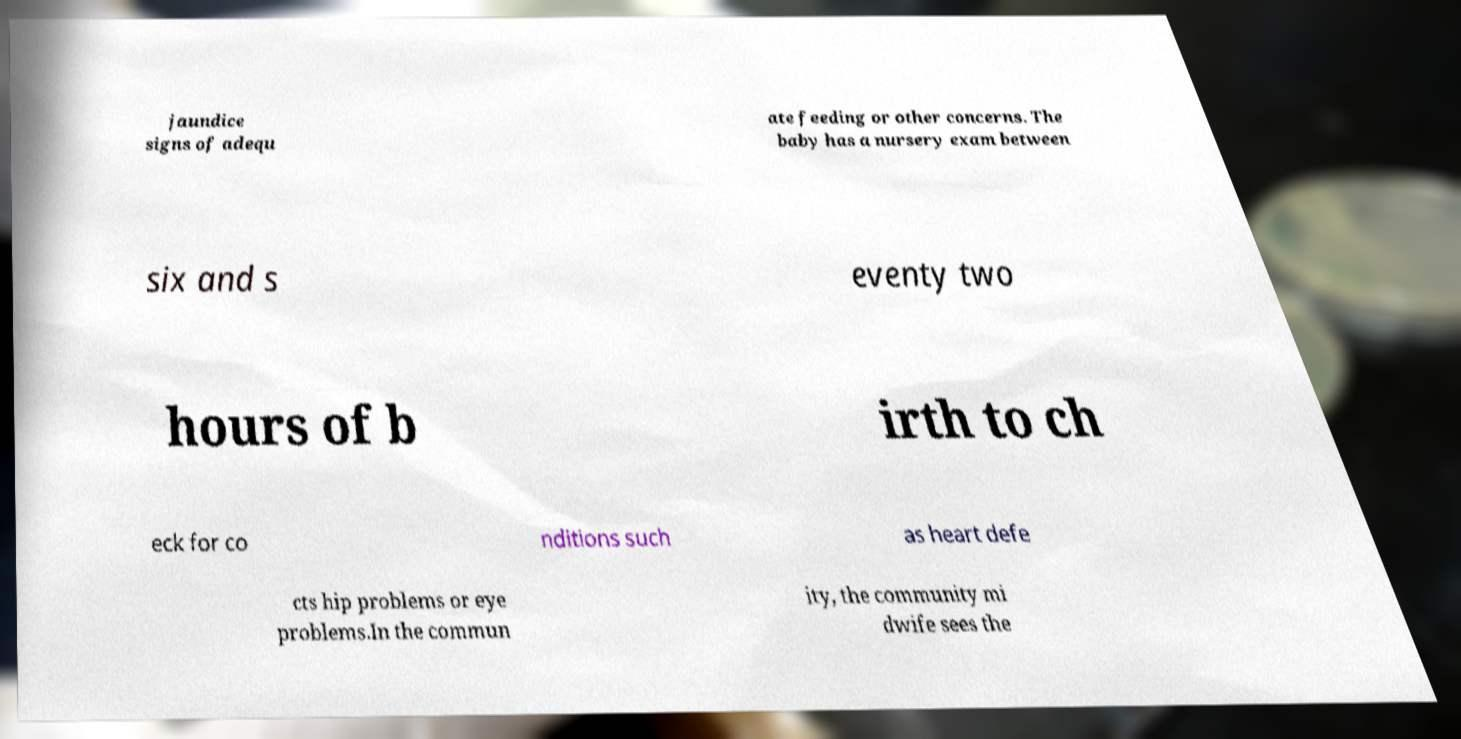There's text embedded in this image that I need extracted. Can you transcribe it verbatim? jaundice signs of adequ ate feeding or other concerns. The baby has a nursery exam between six and s eventy two hours of b irth to ch eck for co nditions such as heart defe cts hip problems or eye problems.In the commun ity, the community mi dwife sees the 